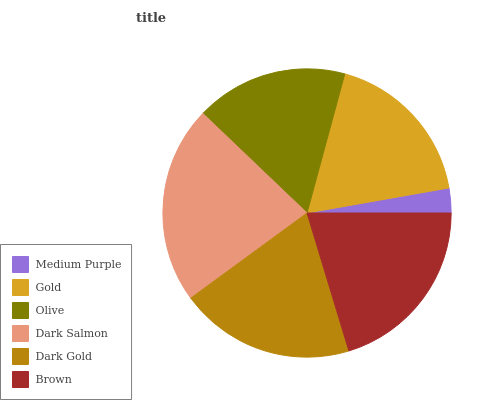Is Medium Purple the minimum?
Answer yes or no. Yes. Is Dark Salmon the maximum?
Answer yes or no. Yes. Is Gold the minimum?
Answer yes or no. No. Is Gold the maximum?
Answer yes or no. No. Is Gold greater than Medium Purple?
Answer yes or no. Yes. Is Medium Purple less than Gold?
Answer yes or no. Yes. Is Medium Purple greater than Gold?
Answer yes or no. No. Is Gold less than Medium Purple?
Answer yes or no. No. Is Dark Gold the high median?
Answer yes or no. Yes. Is Gold the low median?
Answer yes or no. Yes. Is Medium Purple the high median?
Answer yes or no. No. Is Dark Gold the low median?
Answer yes or no. No. 